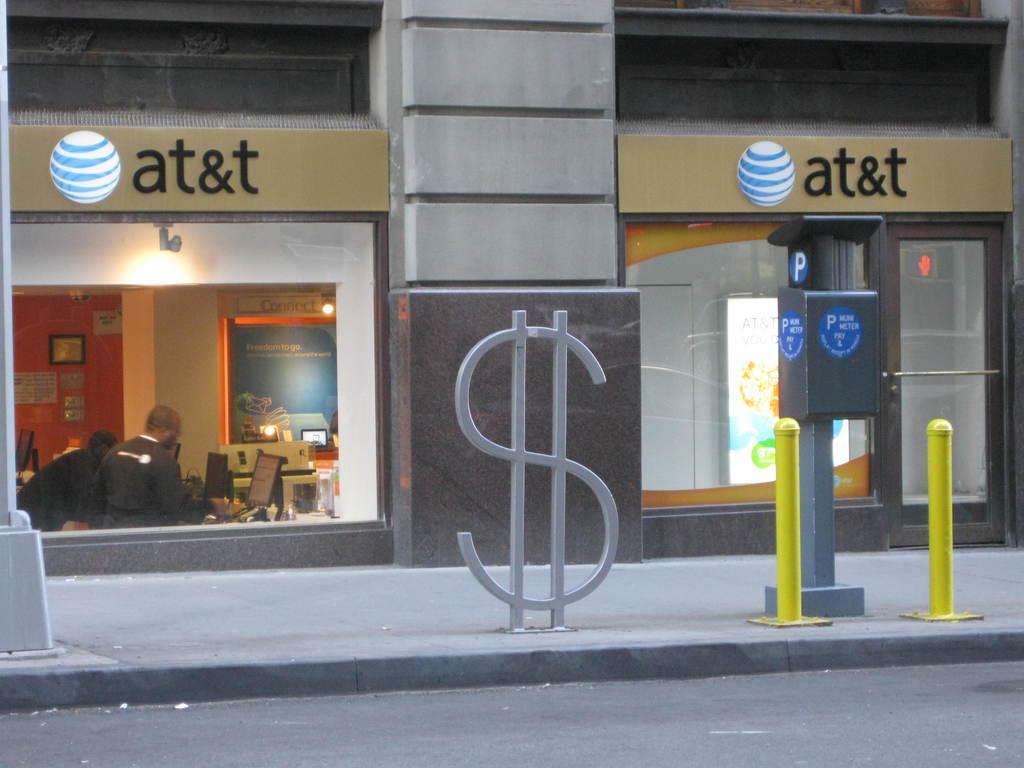Please provide a concise description of this image. In this image I can see the road, the side walk, few yellow colored poles, a parking meter, a dollar shaped metal rods, a silver colored metal pole on the side walk. In the background I can see a building and inside the building I can see two persons standing in front of a desk and on the desk I can see few monitors and I can see the orange colored wall and few papers and a photo frame attached to the wall. 